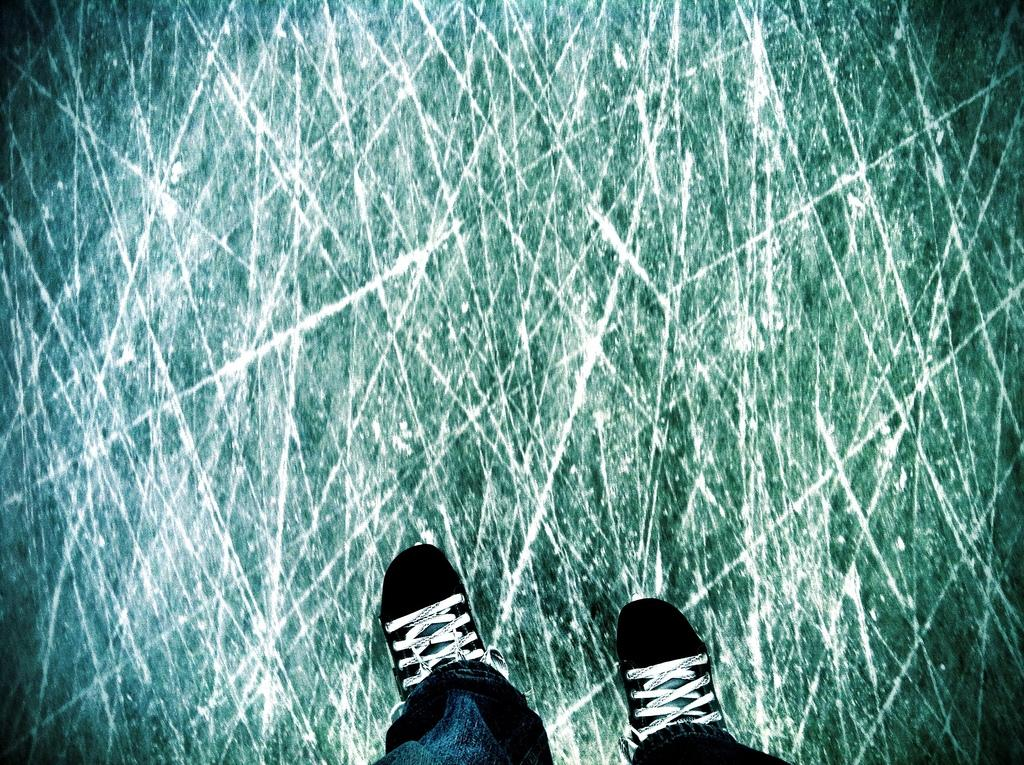What part of a person can be seen in the image? There are legs of a person in the image. What type of footwear is the person wearing? The person is wearing black colored shoes. What surface are the shoes standing on? The shoes are standing on a floor. What type of cracker is the duck holding in the image? There is no duck or cracker present in the image. 